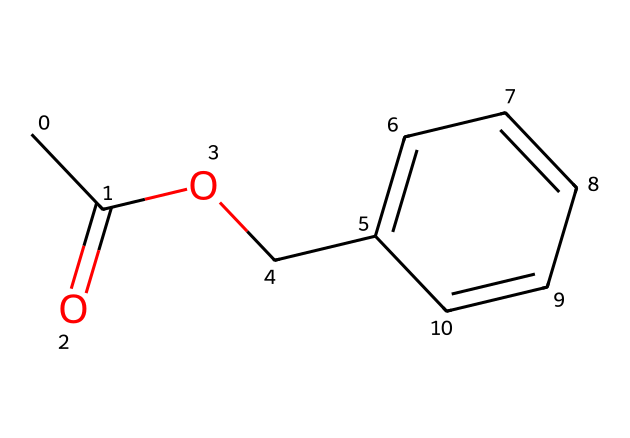What is the molecular formula of benzyl acetate? By analyzing the SMILES representation, we count the atoms involved: there are 9 carbon (C), 10 hydrogen (H), and 2 oxygen (O) atoms. Thus, the molecular formula is derived as C9H10O2.
Answer: C9H10O2 How many carbon atoms are in this compound? From the SMILES representation, we can identify there are 9 carbon atoms represented within the structure.
Answer: 9 What functional groups are present in benzyl acetate? The SMILES shows the presence of an ester group (–COO–) and an aromatic ring (the presence of benzene indicates aromaticity). Therefore, the functional groups present are ester and aromatic.
Answer: ester, aromatic What type of compound is benzyl acetate? Benzyl acetate is classified as an ester due to the presence of the –COO– group in its structure. This classification is based on the functional groups present in the molecular structure.
Answer: ester Why is benzyl acetate used in fragrances? Benzyl acetate is known for its sweet, floral aroma, similar to jasmine. Its specific molecular structure contributes to its appealing scent, making it a common ingredient in fragrances and candles.
Answer: sweet, floral aroma How does the structure of benzyl acetate contribute to its volatility? The presence of the ester functional group along with the molecular weight and the nature of the carbon chain leads to higher volatility in benzyl acetate. The lighter molecular weight compared to heavier compounds allows it to evaporate easily.
Answer: higher volatility What would happen if the ester group was not present? If the ester group were absent, benzyl acetate would not exist as it is because the defining characteristic of an ester is the –COO– linkage. Thus, it would result in a different compound altogether, losing its properties and fragrance.
Answer: different compound 